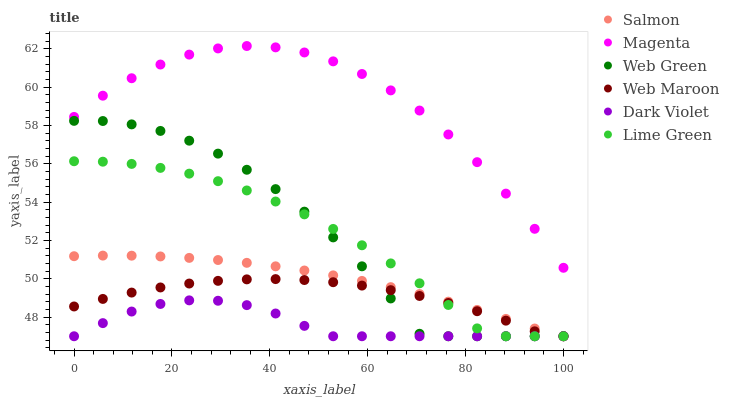Does Dark Violet have the minimum area under the curve?
Answer yes or no. Yes. Does Magenta have the maximum area under the curve?
Answer yes or no. Yes. Does Web Maroon have the minimum area under the curve?
Answer yes or no. No. Does Web Maroon have the maximum area under the curve?
Answer yes or no. No. Is Salmon the smoothest?
Answer yes or no. Yes. Is Web Green the roughest?
Answer yes or no. Yes. Is Web Maroon the smoothest?
Answer yes or no. No. Is Web Maroon the roughest?
Answer yes or no. No. Does Salmon have the lowest value?
Answer yes or no. Yes. Does Magenta have the lowest value?
Answer yes or no. No. Does Magenta have the highest value?
Answer yes or no. Yes. Does Web Maroon have the highest value?
Answer yes or no. No. Is Web Green less than Magenta?
Answer yes or no. Yes. Is Magenta greater than Dark Violet?
Answer yes or no. Yes. Does Web Green intersect Salmon?
Answer yes or no. Yes. Is Web Green less than Salmon?
Answer yes or no. No. Is Web Green greater than Salmon?
Answer yes or no. No. Does Web Green intersect Magenta?
Answer yes or no. No. 